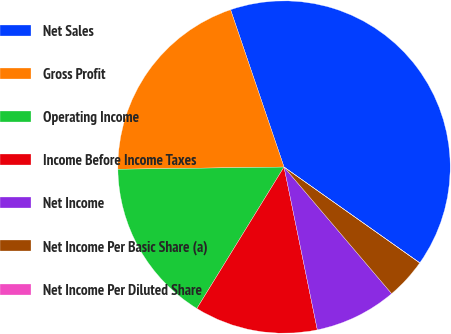Convert chart to OTSL. <chart><loc_0><loc_0><loc_500><loc_500><pie_chart><fcel>Net Sales<fcel>Gross Profit<fcel>Operating Income<fcel>Income Before Income Taxes<fcel>Net Income<fcel>Net Income Per Basic Share (a)<fcel>Net Income Per Diluted Share<nl><fcel>39.99%<fcel>20.0%<fcel>16.0%<fcel>12.0%<fcel>8.0%<fcel>4.0%<fcel>0.01%<nl></chart> 